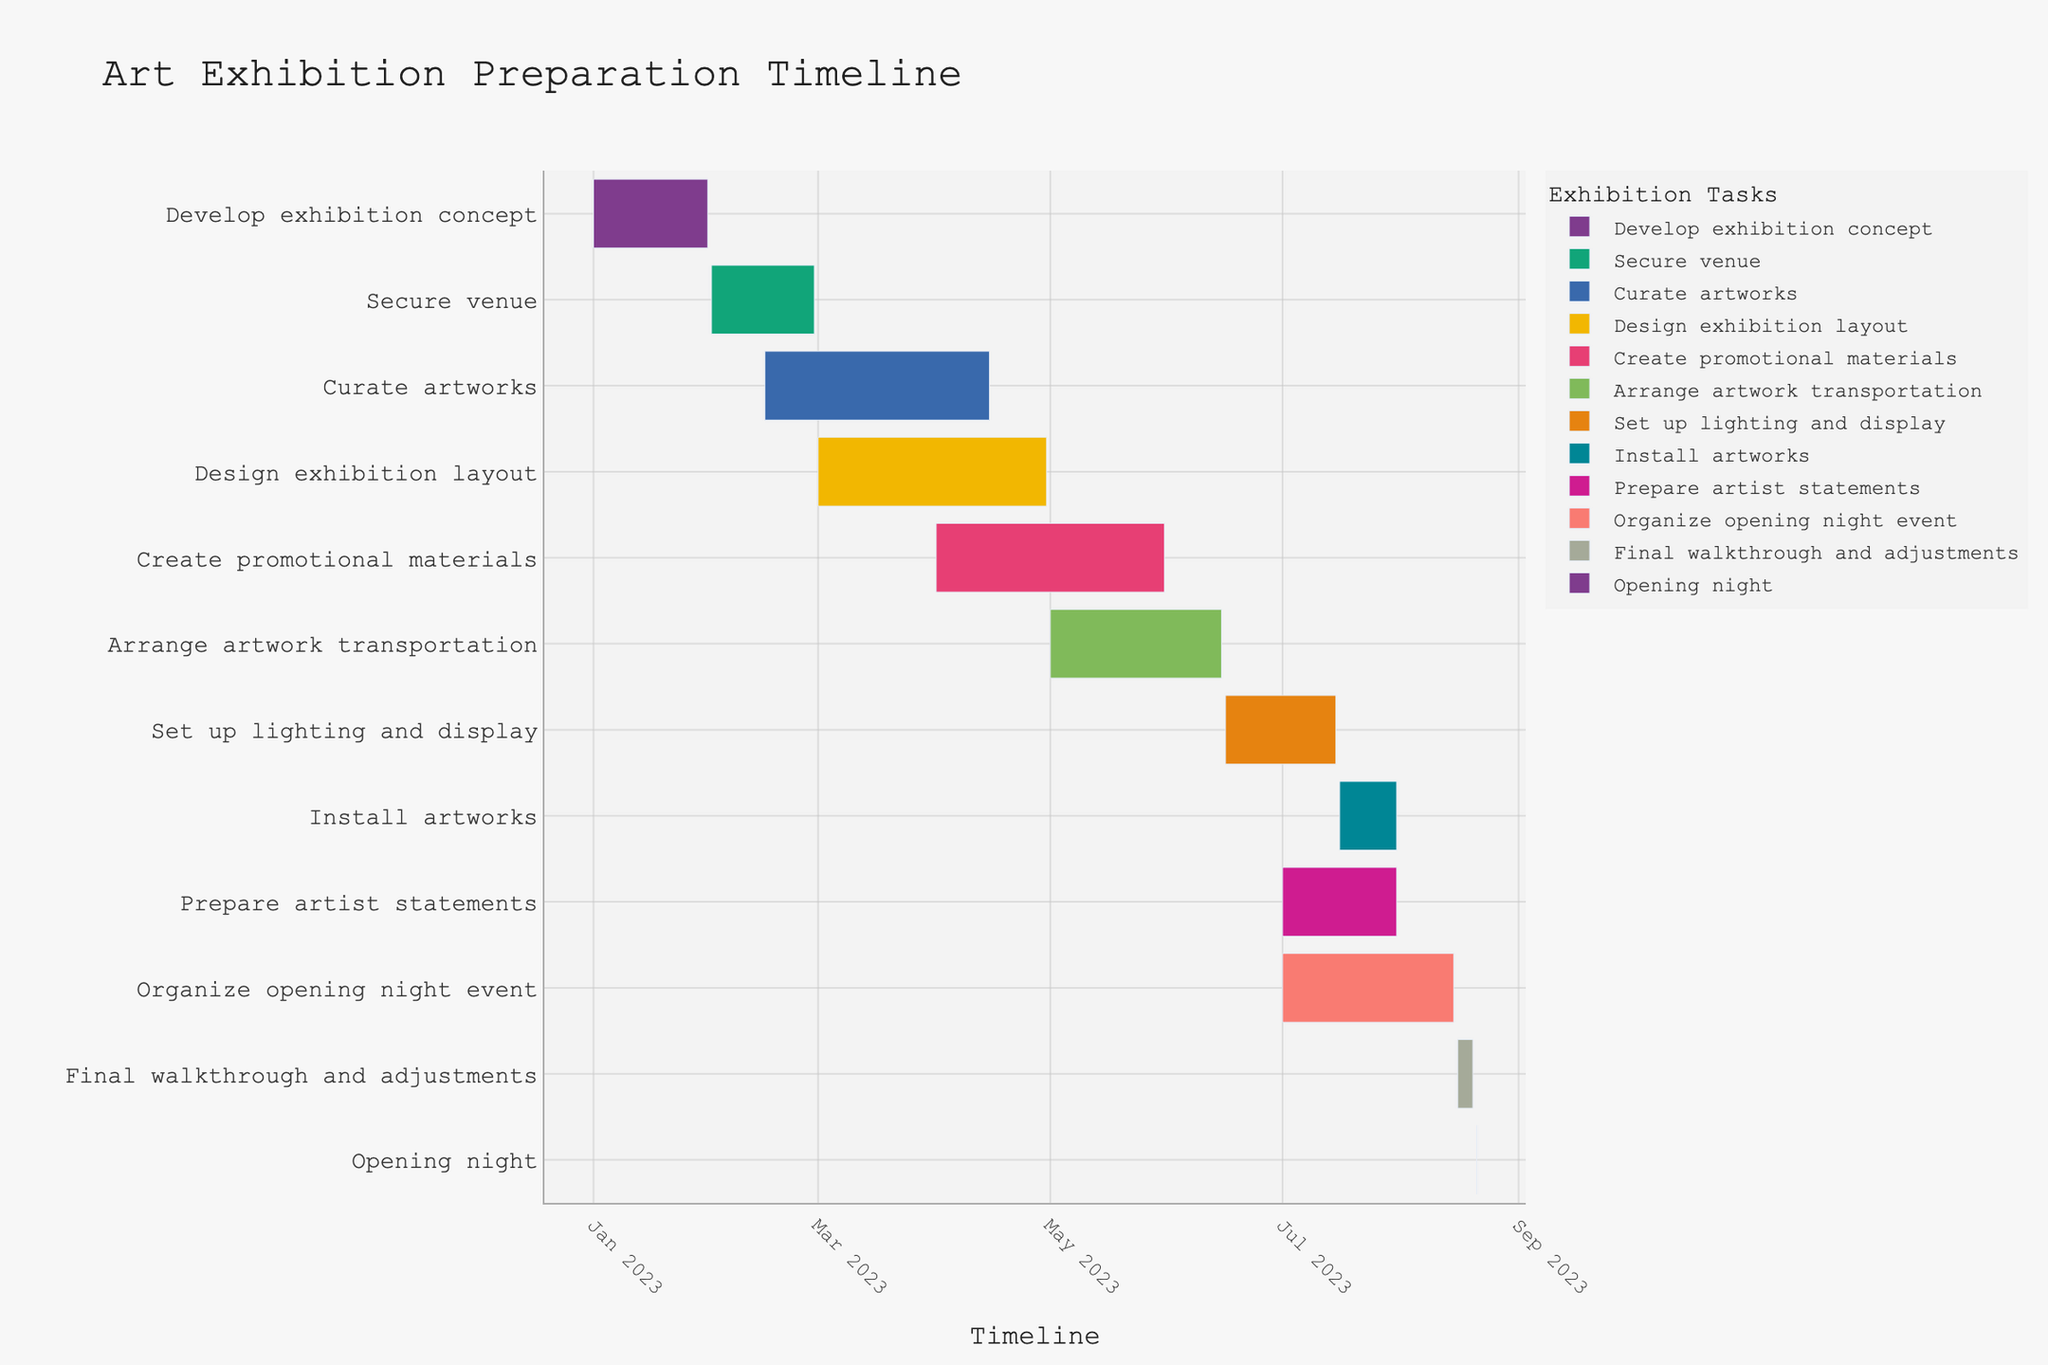How long did it take to develop the exhibition concept? To find the duration, look at the start and end dates of the "Develop exhibition concept" task. The task began on January 1, 2023, and ended on January 31, 2023. Therefore, it took 31 days.
Answer: 31 days What is the title of the Gantt Chart? The title is typically displayed at the top of the Gantt chart. In this case, the title is "Art Exhibition Preparation Timeline".
Answer: Art Exhibition Preparation Timeline Which task has the longest duration in the preparation timeline? To identify the longest task, compare the duration of all tasks. "Curate artworks" spans from February 15, 2023, to April 15, 2023, lasting 60 days. This is the longest duration among the tasks.
Answer: Curate artworks How many tasks are scheduled to start in July? Look at the start dates and count the tasks beginning in July. "Prepare artist statements," "Install artworks," and "Organize opening night event" all start in July. Therefore, there are three tasks starting in July.
Answer: 3 tasks When does artwork transportation begin and end? The start and end dates are indicated in the Gantt chart. "Arrange artwork transportation" starts on May 1, 2023, and ends on June 15, 2023.
Answer: May 1, 2023, to June 15, 2023 Which task is scheduled just before the opening night event? To find the task before the opening night, look for the task ending right before August 21, 2023. "Final walkthrough and adjustments" ends on August 20, 2023, making it the task just before the opening night event.
Answer: Final walkthrough and adjustments Which two tasks have overlapping timelines in April? Check the timelines for tasks covering April. "Curate artworks" goes from February 15 to April 15, and "Design exhibition layout" goes from March 1 to April 30. Both tasks overlap in April.
Answer: Curate artworks and Design exhibition layout How many days are allocated for setting up lighting and display? The task "Set up lighting and display" starts on June 16, 2023, and ends on July 15, 2023. The duration is 30 days.
Answer: 30 days By how many days does the creation of promotional materials overlap with arranging artwork transportation? "Create promotional materials" runs from April 1, 2023, to May 31, 2023, and "Arrange artwork transportation" begins on May 1, 2023. They overlap from May 1 to May 31, which is a total of 31 days.
Answer: 31 days What is the first task to start in the preparation timeline? The first task in the timeline is the one with the earliest start date. "Develop exhibition concept" starts on January 1, 2023, making it the first task.
Answer: Develop exhibition concept 